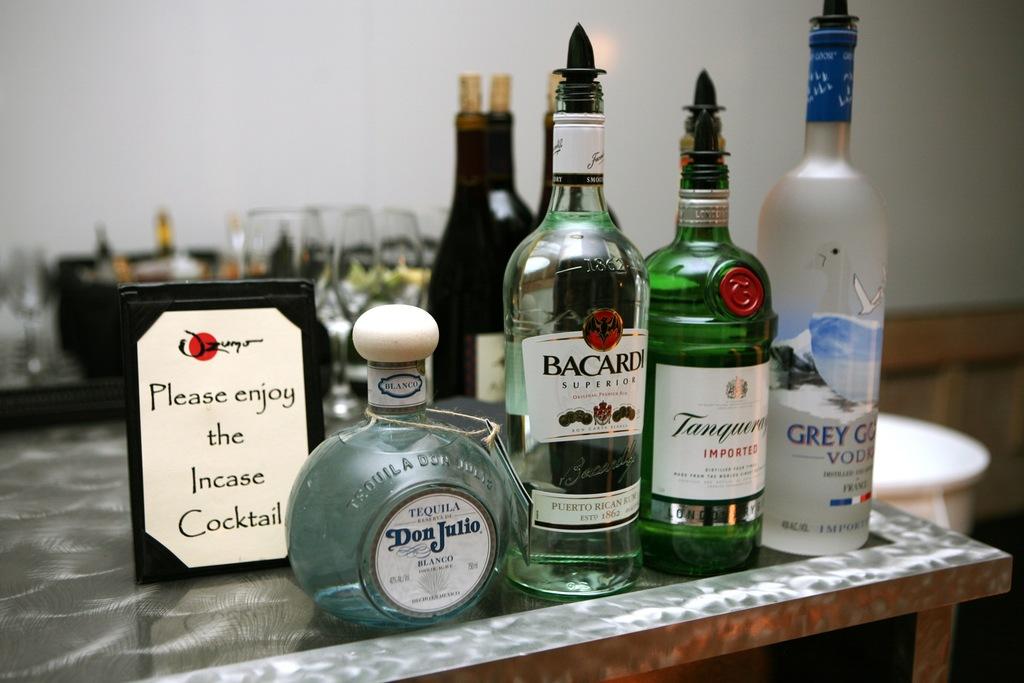What brand of tequila is in the short, round bottle/?
Keep it short and to the point. Don julio. 